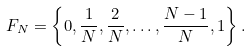<formula> <loc_0><loc_0><loc_500><loc_500>F _ { N } = \left \{ 0 , \frac { 1 } { N } , \frac { 2 } { N } , \dots , \frac { N - 1 } N , 1 \right \} .</formula> 